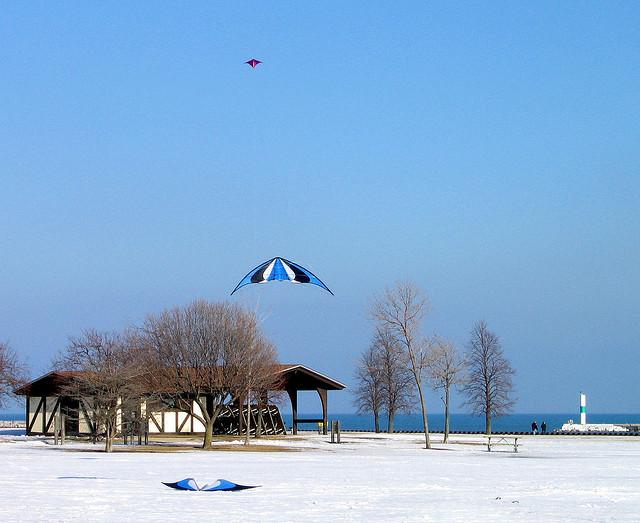What is the wooden structure?
Be succinct. Shelter. What is in the air?
Concise answer only. Kite. Is the ground covered with snow?
Keep it brief. Yes. 